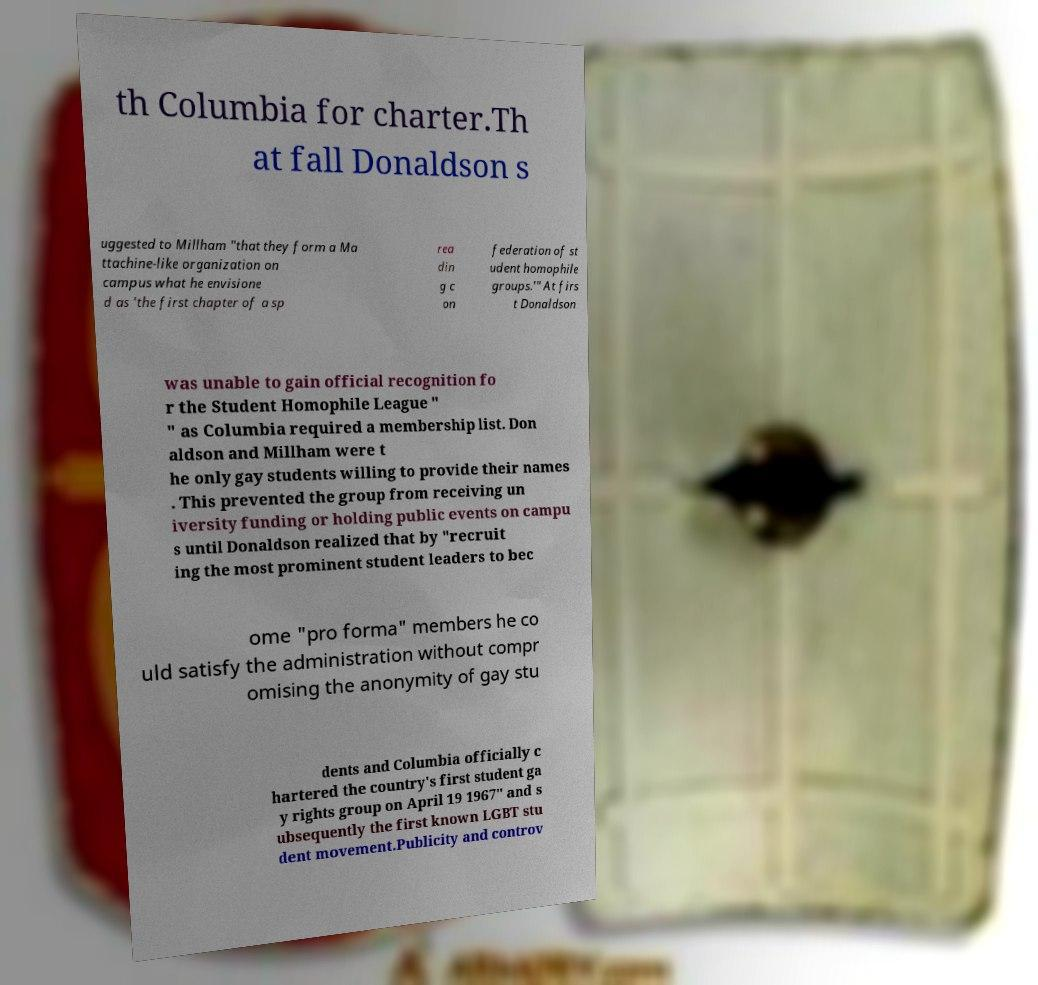What messages or text are displayed in this image? I need them in a readable, typed format. th Columbia for charter.Th at fall Donaldson s uggested to Millham "that they form a Ma ttachine-like organization on campus what he envisione d as 'the first chapter of a sp rea din g c on federation of st udent homophile groups.'" At firs t Donaldson was unable to gain official recognition fo r the Student Homophile League " " as Columbia required a membership list. Don aldson and Millham were t he only gay students willing to provide their names . This prevented the group from receiving un iversity funding or holding public events on campu s until Donaldson realized that by "recruit ing the most prominent student leaders to bec ome "pro forma" members he co uld satisfy the administration without compr omising the anonymity of gay stu dents and Columbia officially c hartered the country's first student ga y rights group on April 19 1967" and s ubsequently the first known LGBT stu dent movement.Publicity and controv 